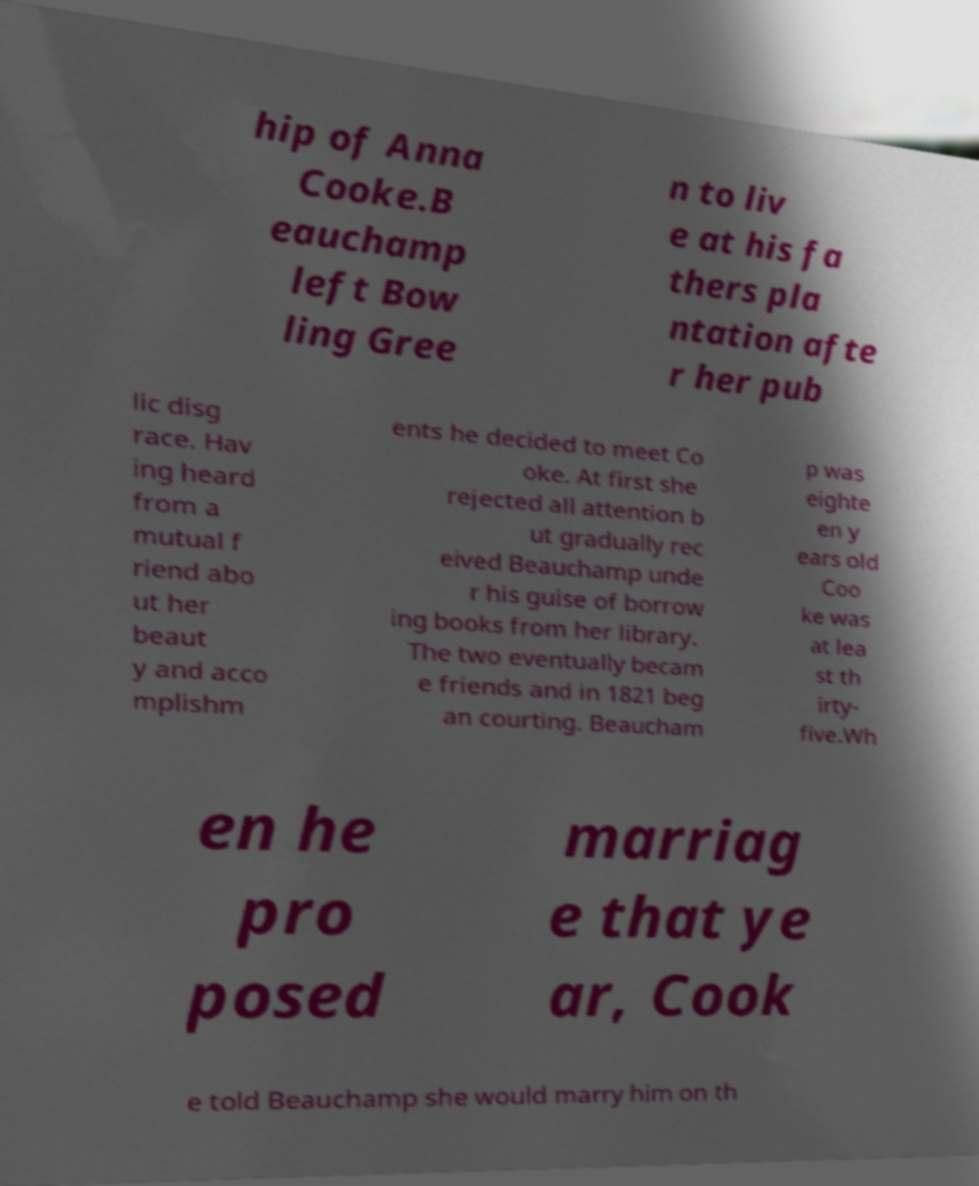Please identify and transcribe the text found in this image. hip of Anna Cooke.B eauchamp left Bow ling Gree n to liv e at his fa thers pla ntation afte r her pub lic disg race. Hav ing heard from a mutual f riend abo ut her beaut y and acco mplishm ents he decided to meet Co oke. At first she rejected all attention b ut gradually rec eived Beauchamp unde r his guise of borrow ing books from her library. The two eventually becam e friends and in 1821 beg an courting. Beaucham p was eighte en y ears old Coo ke was at lea st th irty- five.Wh en he pro posed marriag e that ye ar, Cook e told Beauchamp she would marry him on th 